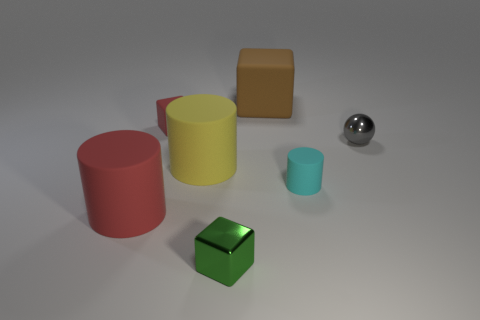Subtract all cyan cubes. Subtract all blue balls. How many cubes are left? 3 Add 3 big yellow objects. How many objects exist? 10 Subtract all spheres. How many objects are left? 6 Subtract all cyan cylinders. Subtract all metallic balls. How many objects are left? 5 Add 2 tiny metal cubes. How many tiny metal cubes are left? 3 Add 3 small matte things. How many small matte things exist? 5 Subtract 0 blue spheres. How many objects are left? 7 